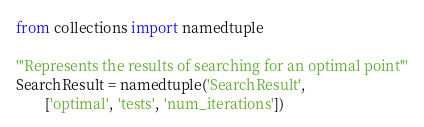Convert code to text. <code><loc_0><loc_0><loc_500><loc_500><_Python_>from collections import namedtuple

'''Represents the results of searching for an optimal point'''
SearchResult = namedtuple('SearchResult',
        ['optimal', 'tests', 'num_iterations'])
</code> 